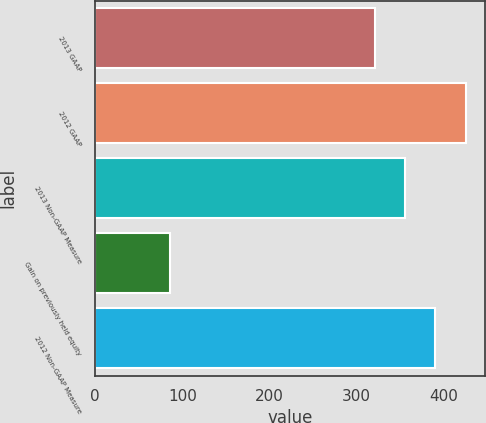Convert chart. <chart><loc_0><loc_0><loc_500><loc_500><bar_chart><fcel>2013 GAAP<fcel>2012 GAAP<fcel>2013 Non-GAAP Measure<fcel>Gain on previously held equity<fcel>2012 Non-GAAP Measure<nl><fcel>321.3<fcel>425.6<fcel>355.27<fcel>85.9<fcel>389.24<nl></chart> 